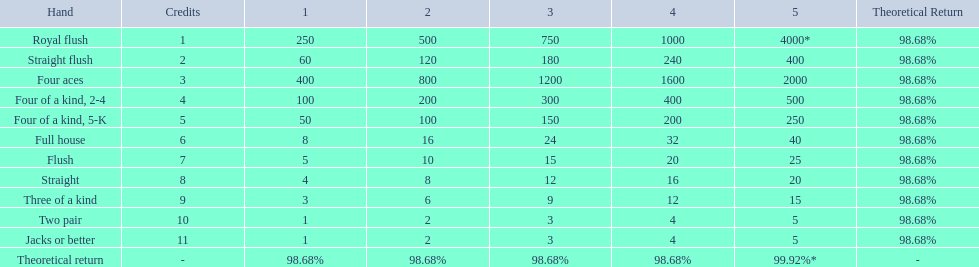What are the hands in super aces? Royal flush, Straight flush, Four aces, Four of a kind, 2-4, Four of a kind, 5-K, Full house, Flush, Straight, Three of a kind, Two pair, Jacks or better. What hand gives the highest credits? Royal flush. 